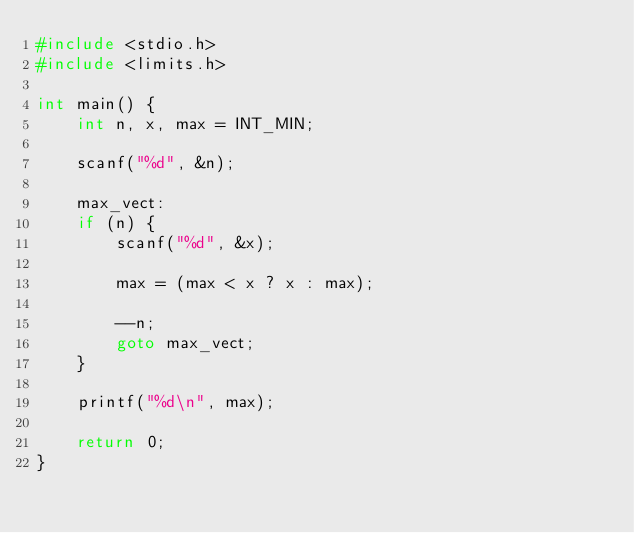<code> <loc_0><loc_0><loc_500><loc_500><_C_>#include <stdio.h>
#include <limits.h>

int main() {
    int n, x, max = INT_MIN;

    scanf("%d", &n);

    max_vect:
    if (n) {
        scanf("%d", &x);

        max = (max < x ? x : max);

        --n;
        goto max_vect;
    }

    printf("%d\n", max);

    return 0;
}</code> 